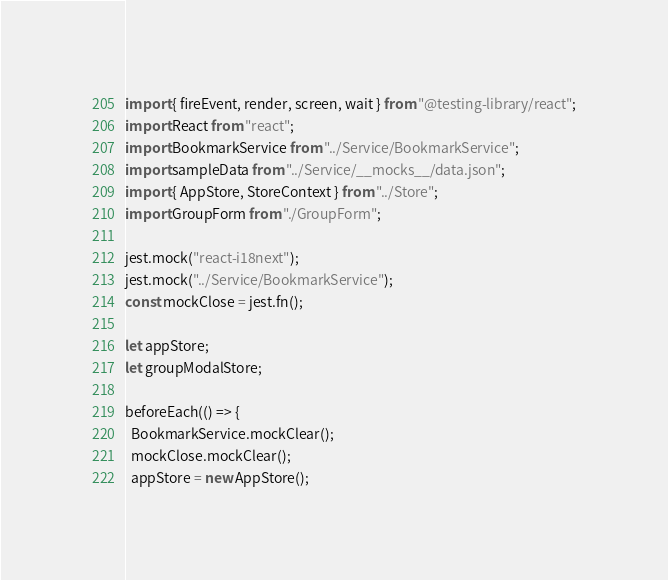Convert code to text. <code><loc_0><loc_0><loc_500><loc_500><_JavaScript_>import { fireEvent, render, screen, wait } from "@testing-library/react";
import React from "react";
import BookmarkService from "../Service/BookmarkService";
import sampleData from "../Service/__mocks__/data.json";
import { AppStore, StoreContext } from "../Store";
import GroupForm from "./GroupForm";

jest.mock("react-i18next");
jest.mock("../Service/BookmarkService");
const mockClose = jest.fn();

let appStore;
let groupModalStore;

beforeEach(() => {
  BookmarkService.mockClear();
  mockClose.mockClear();
  appStore = new AppStore();</code> 